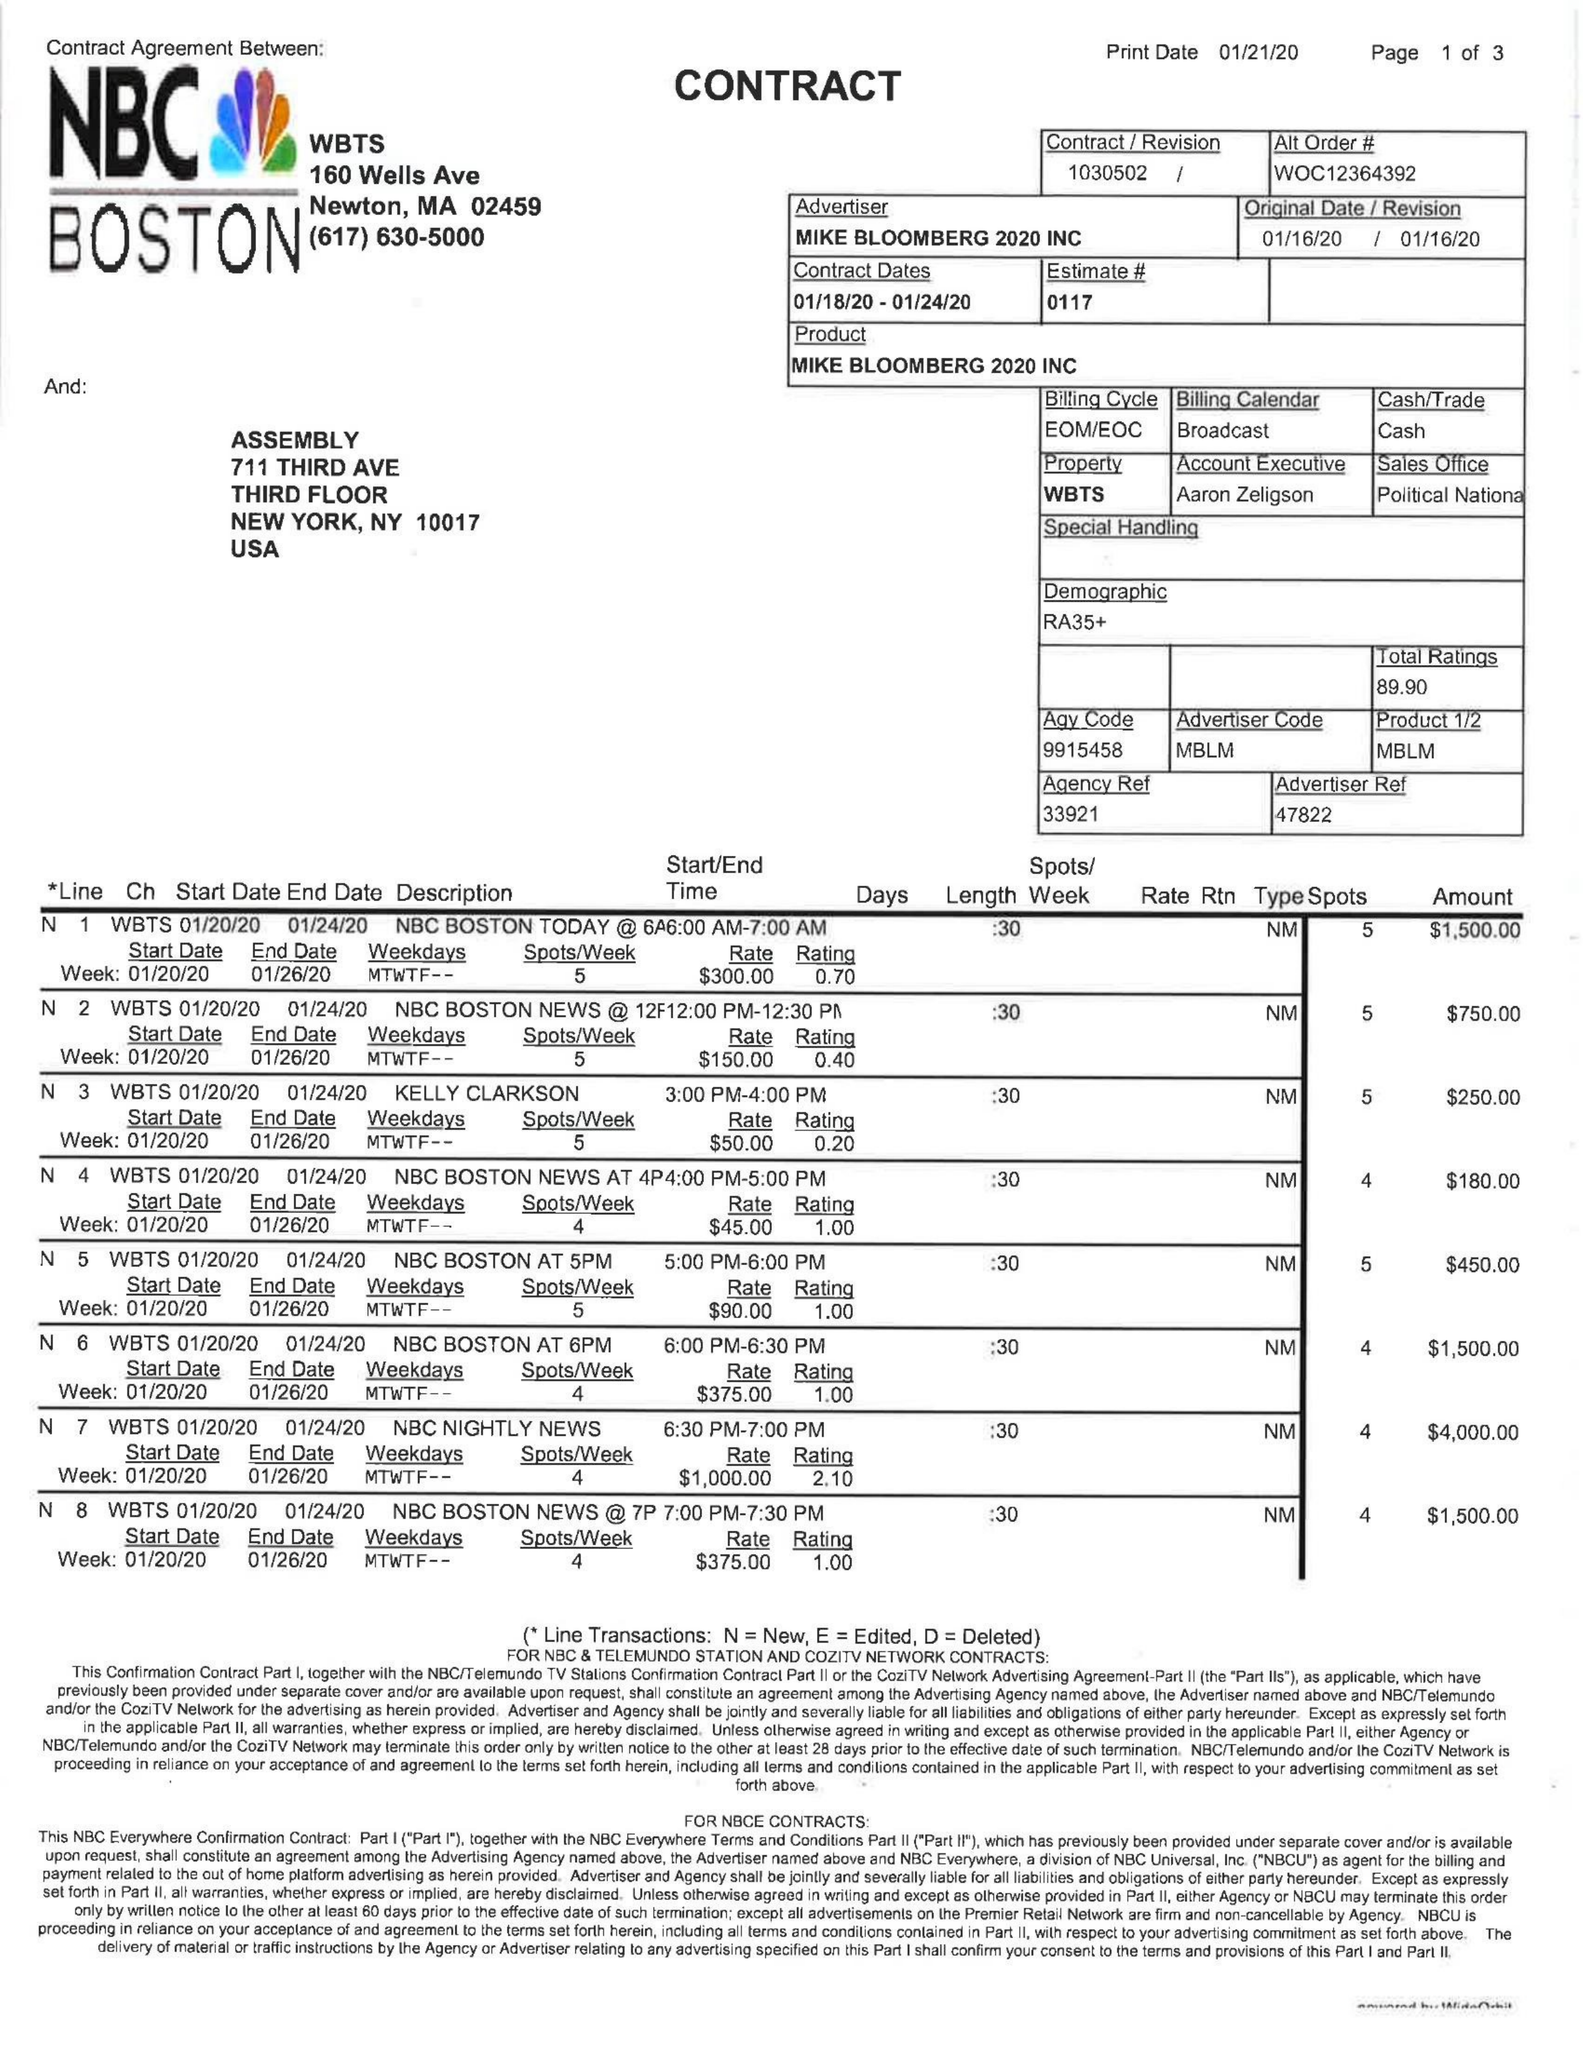What is the value for the flight_from?
Answer the question using a single word or phrase. 01/18/20 